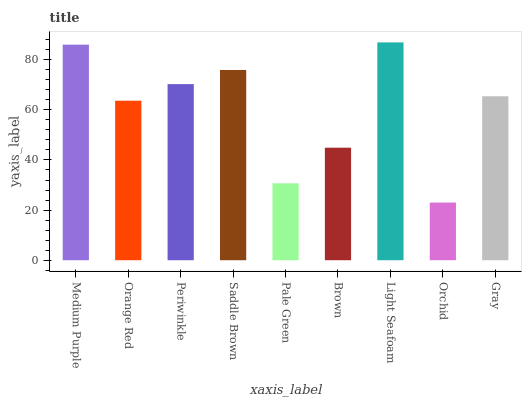Is Orchid the minimum?
Answer yes or no. Yes. Is Light Seafoam the maximum?
Answer yes or no. Yes. Is Orange Red the minimum?
Answer yes or no. No. Is Orange Red the maximum?
Answer yes or no. No. Is Medium Purple greater than Orange Red?
Answer yes or no. Yes. Is Orange Red less than Medium Purple?
Answer yes or no. Yes. Is Orange Red greater than Medium Purple?
Answer yes or no. No. Is Medium Purple less than Orange Red?
Answer yes or no. No. Is Gray the high median?
Answer yes or no. Yes. Is Gray the low median?
Answer yes or no. Yes. Is Orange Red the high median?
Answer yes or no. No. Is Pale Green the low median?
Answer yes or no. No. 